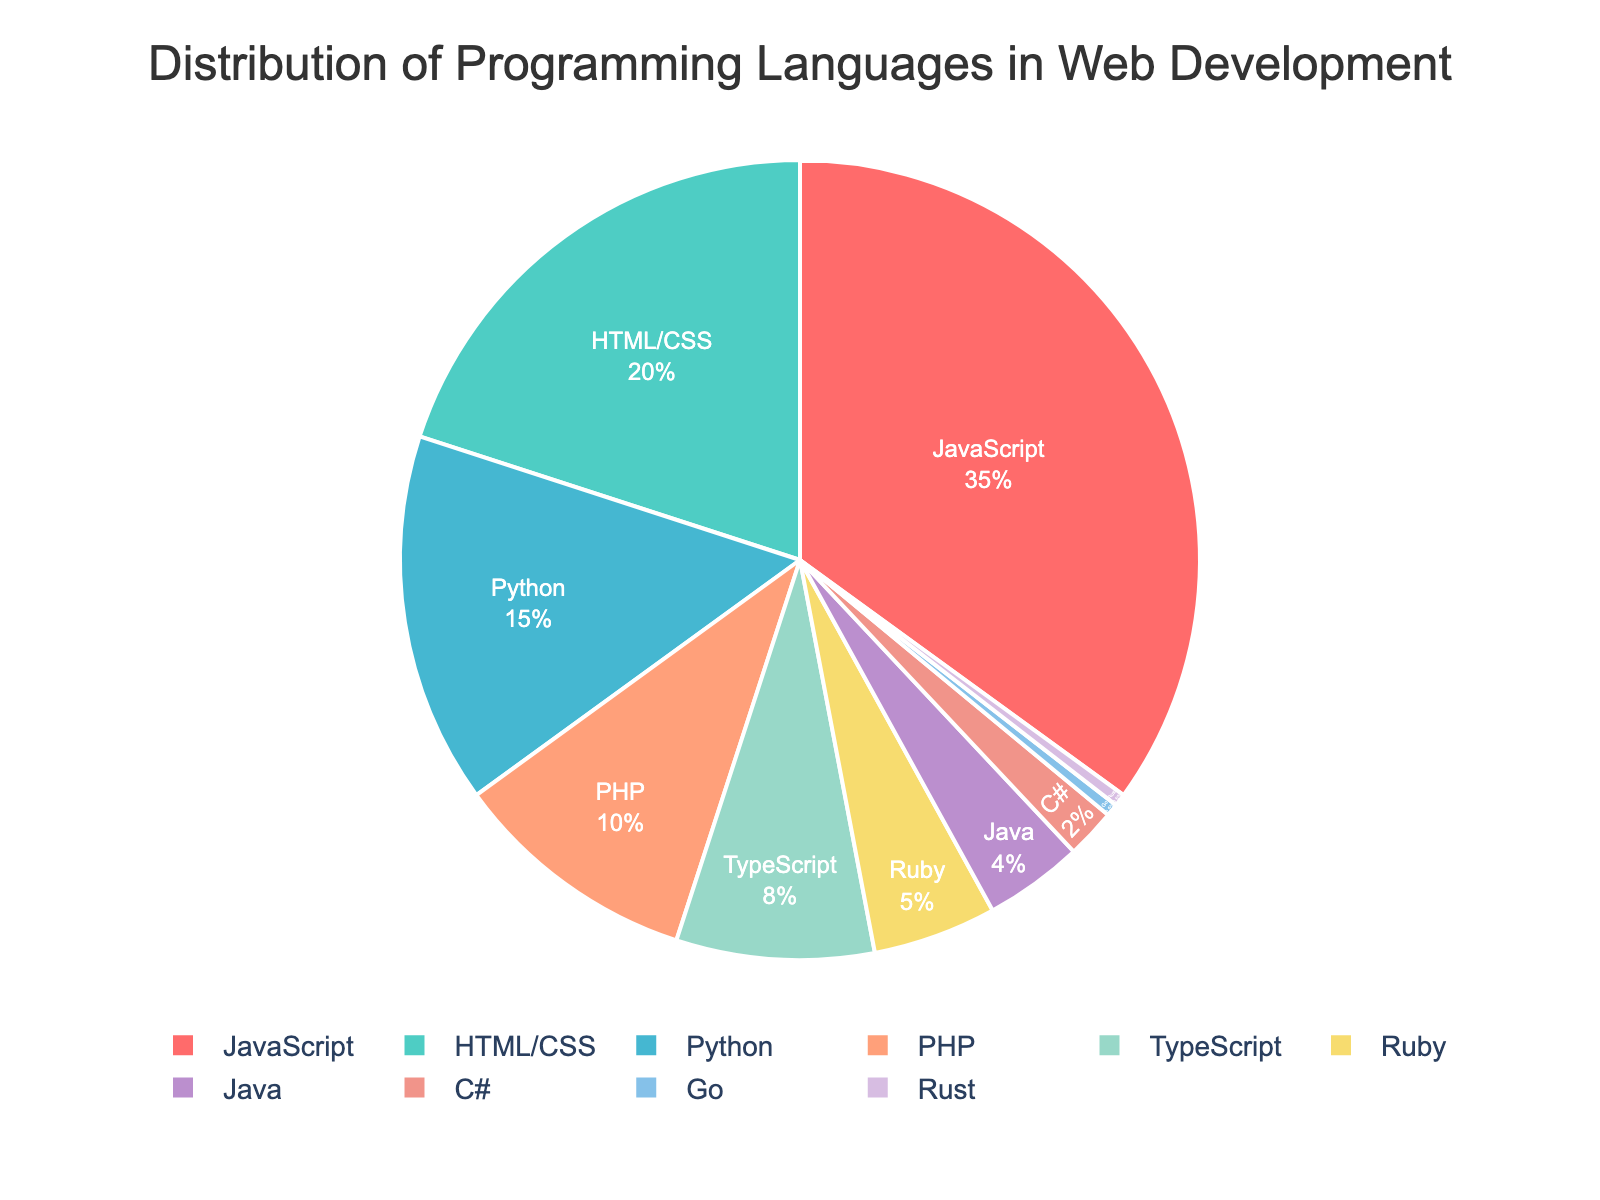What percentage of the languages have usage percentages above 10%? Look at the pie chart and identify the languages with usage percentages greater than 10%, which are JavaScript and HTML/CSS and Python, which sum to 3 out of 10 languages. Calculate the percentage as (3/10) * 100%.
Answer: 30% Which language has the smallest representation in web development according to the pie chart? Examine the pie chart and identify the smallest wedge. Go and Rust both share the smallest, each with 0.5%.
Answer: Go and Rust What is the combined percentage usage of TypeScript and Ruby? From the pie chart, find the percentage usage of TypeScript (8%) and Ruby (5%). Add them together: 8% + 5%.
Answer: 13% How much more popular is Python compared to PHP in web development? Identify the percentage for Python (15%) and PHP (10%). Subtract PHP's percentage from Python's: 15% - 10%.
Answer: 5% Which language has the most usage in web development, and what is its percentage? Look at the pie chart and locate the largest segment. JavaScript is the largest segment with 35%.
Answer: JavaScript, 35% Compare the usage of Java and C#. Which one is used more? Find Java's percentage (4%) and C#'s percentage (2%) on the pie chart. Java’s 4% is greater than C#’s 2%.
Answer: Java What is the color associated with PHP in the pie chart? Examine the pie chart and locate the wedge for PHP (10%). Identify its color visually.
Answer: Orange Calculate the difference in usage between HTML/CSS and TypeScript. Identify HTML/CSS's percentage (20%) and TypeScript's percentage (8%). Subtract TypeScript’s percentage from HTML/CSS’s: 20% - 8%.
Answer: 12% What percentage of languages have usage below 10%? Identify the languages below 10%: TypeScript, Ruby, Java, C#, Go, Rust. There are 6 out of 10 languages. Calculate the percentage as (6/10) * 100%.
Answer: 60% Is the total usage of JavaScript and HTML/CSS greater than the combined usage of Python, PHP, and TypeScript? Calculate the sum of JavaScript (35%) and HTML/CSS (20%): 35% + 20% = 55%. Compare it with the sum of Python (15%), PHP (10%), and TypeScript (8%): 15% + 10% + 8% = 33%. 55% is greater than 33%.
Answer: Yes 